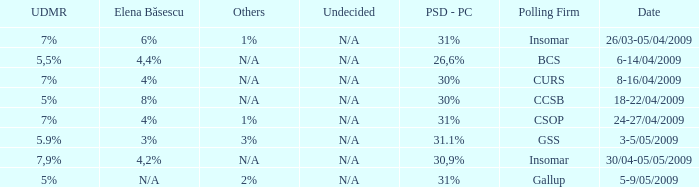Help me parse the entirety of this table. {'header': ['UDMR', 'Elena Băsescu', 'Others', 'Undecided', 'PSD - PC', 'Polling Firm', 'Date'], 'rows': [['7%', '6%', '1%', 'N/A', '31%', 'Insomar', '26/03-05/04/2009'], ['5,5%', '4,4%', 'N/A', 'N/A', '26,6%', 'BCS', '6-14/04/2009'], ['7%', '4%', 'N/A', 'N/A', '30%', 'CURS', '8-16/04/2009'], ['5%', '8%', 'N/A', 'N/A', '30%', 'CCSB', '18-22/04/2009'], ['7%', '4%', '1%', 'N/A', '31%', 'CSOP', '24-27/04/2009'], ['5.9%', '3%', '3%', 'N/A', '31.1%', 'GSS', '3-5/05/2009'], ['7,9%', '4,2%', 'N/A', 'N/A', '30,9%', 'Insomar', '30/04-05/05/2009'], ['5%', 'N/A', '2%', 'N/A', '31%', 'Gallup', '5-9/05/2009']]} What date has the others of 2%? 5-9/05/2009. 